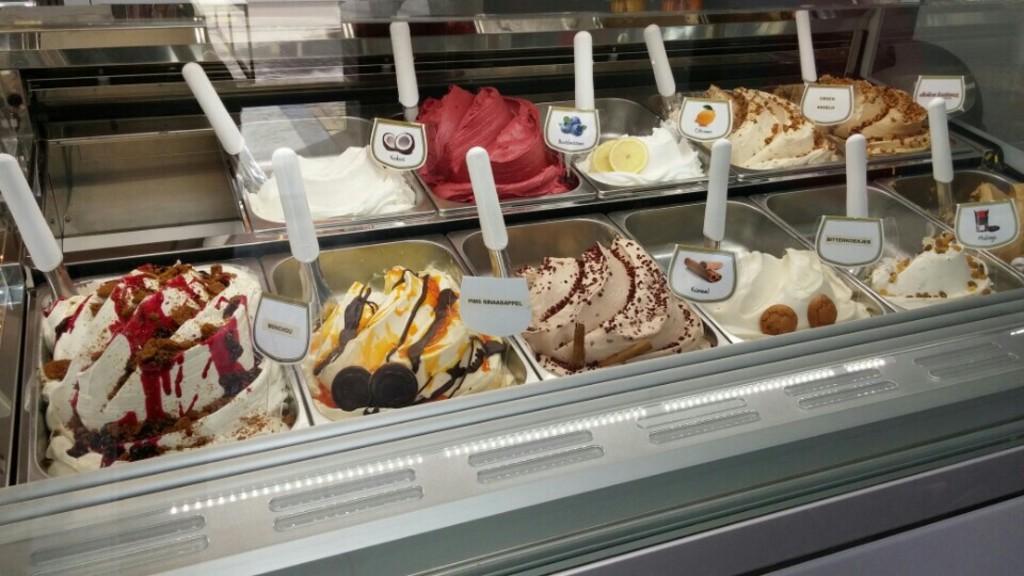How would you summarize this image in a sentence or two? In this image there are different flavored ice creams in the vessels. There are boards with pictures and text near to the vessels. In the foreground there is a glass. In the bottom right there is a metal. 